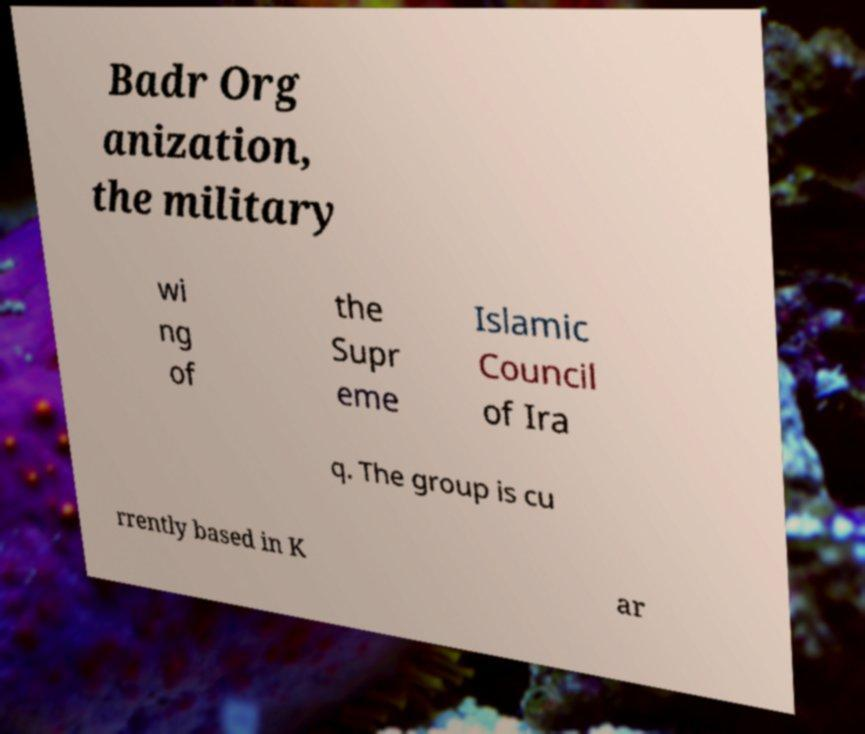Please identify and transcribe the text found in this image. Badr Org anization, the military wi ng of the Supr eme Islamic Council of Ira q. The group is cu rrently based in K ar 